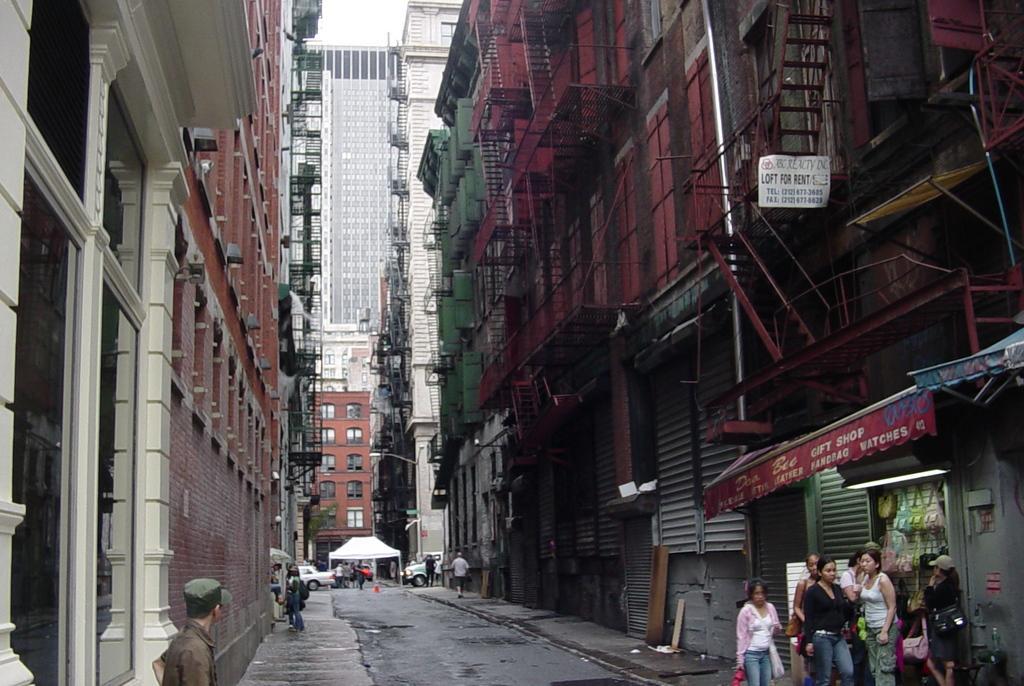In one or two sentences, can you explain what this image depicts? In this image there are some persons standing in the bottom of this image, and there is a shop in the bottom left corner of this image. and there are some buildings in the background. There are some cars in the bottom of this image. 